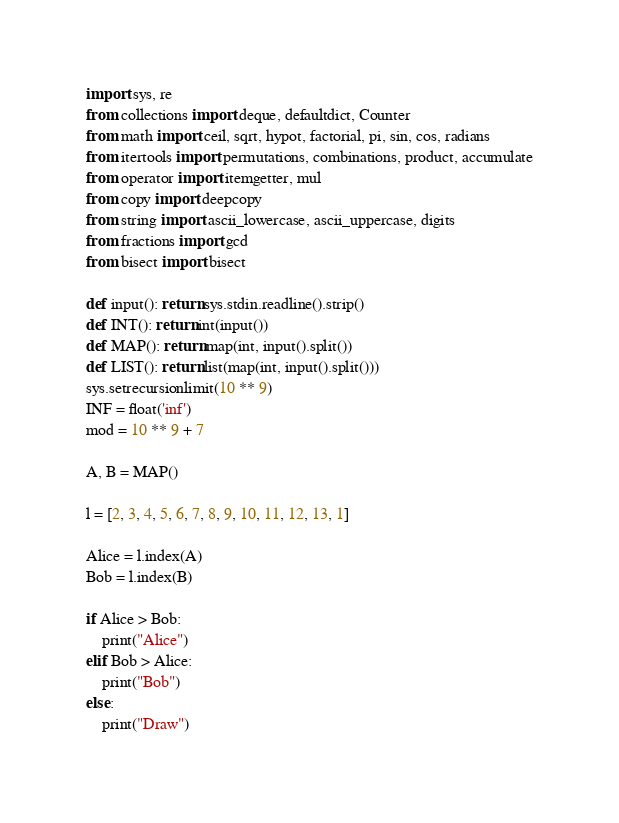Convert code to text. <code><loc_0><loc_0><loc_500><loc_500><_Python_>import sys, re
from collections import deque, defaultdict, Counter
from math import ceil, sqrt, hypot, factorial, pi, sin, cos, radians
from itertools import permutations, combinations, product, accumulate
from operator import itemgetter, mul
from copy import deepcopy
from string import ascii_lowercase, ascii_uppercase, digits
from fractions import gcd
from bisect import bisect

def input(): return sys.stdin.readline().strip()
def INT(): return int(input())
def MAP(): return map(int, input().split())
def LIST(): return list(map(int, input().split()))
sys.setrecursionlimit(10 ** 9)
INF = float('inf')
mod = 10 ** 9 + 7

A, B = MAP()

l = [2, 3, 4, 5, 6, 7, 8, 9, 10, 11, 12, 13, 1]

Alice = l.index(A)
Bob = l.index(B)

if Alice > Bob:
	print("Alice")
elif Bob > Alice:
	print("Bob")
else:
	print("Draw")
</code> 